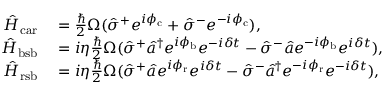<formula> <loc_0><loc_0><loc_500><loc_500>\begin{array} { r l } { \hat { H } _ { c a r } } & = \frac { } { 2 } \Omega ( \hat { \sigma } ^ { + } e ^ { i \phi _ { c } } + \hat { \sigma } ^ { - } e ^ { - i \phi _ { c } } ) , } \\ { \hat { H } _ { b s b } } & = i \eta \frac { } { 2 } \Omega ( \hat { \sigma } ^ { + } \hat { a } ^ { \dagger } e ^ { i \phi _ { b } } e ^ { - i \delta t } - \hat { \sigma } ^ { - } \hat { a } e ^ { - i \phi _ { b } } e ^ { i \delta t } ) , } \\ { \hat { H } _ { r s b } } & = i \eta \frac { } { 2 } \Omega ( \hat { \sigma } ^ { + } \hat { a } e ^ { i \phi _ { r } } e ^ { i \delta t } - \hat { \sigma } ^ { - } \hat { a } ^ { \dagger } e ^ { - i \phi _ { r } } e ^ { - i \delta t } ) , } \end{array}</formula> 